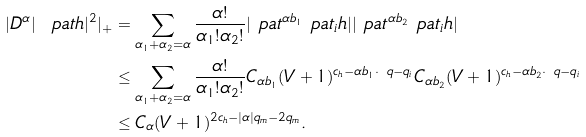Convert formula to latex. <formula><loc_0><loc_0><loc_500><loc_500>| D ^ { \alpha } | \ p a t h | ^ { 2 } | _ { + } & = \sum _ { \alpha _ { 1 } + \alpha _ { 2 } = \alpha } \frac { \alpha ! } { \alpha _ { 1 } ! \alpha _ { 2 } ! } | \ p a t ^ { \alpha b _ { 1 } } \ p a t _ { i } h | | \ p a t ^ { \alpha b _ { 2 } } \ p a t _ { i } h | \\ & \leq \sum _ { \alpha _ { 1 } + \alpha _ { 2 } = \alpha } \frac { \alpha ! } { \alpha _ { 1 } ! \alpha _ { 2 } ! } C _ { \alpha b _ { 1 } } ( V + 1 ) ^ { c _ { h } - \alpha b _ { 1 } \cdot \ q - q _ { i } } C _ { \alpha b _ { 2 } } ( V + 1 ) ^ { c _ { h } - \alpha b _ { 2 } \cdot \ q - q _ { i } } \\ & \leq C _ { \alpha } ( V + 1 ) ^ { 2 c _ { h } - | \alpha | q _ { m } - 2 q _ { m } } .</formula> 